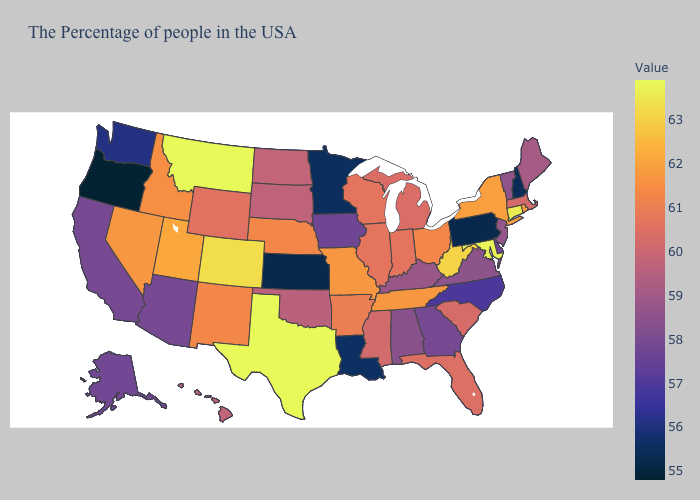Among the states that border Illinois , does Missouri have the highest value?
Quick response, please. Yes. Does Rhode Island have a lower value than Wyoming?
Write a very short answer. No. Does Rhode Island have a higher value than Oklahoma?
Concise answer only. Yes. Does Nevada have the highest value in the USA?
Be succinct. No. Does Montana have the highest value in the West?
Keep it brief. Yes. 